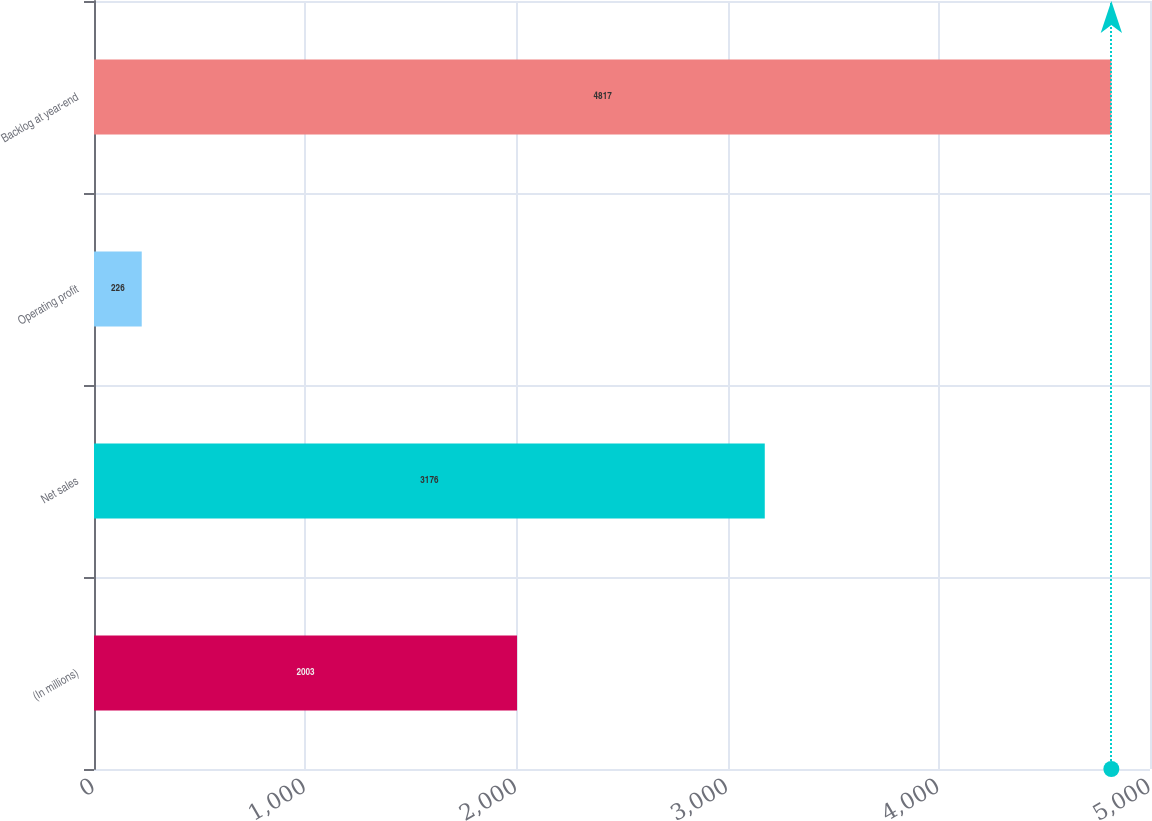<chart> <loc_0><loc_0><loc_500><loc_500><bar_chart><fcel>(In millions)<fcel>Net sales<fcel>Operating profit<fcel>Backlog at year-end<nl><fcel>2003<fcel>3176<fcel>226<fcel>4817<nl></chart> 